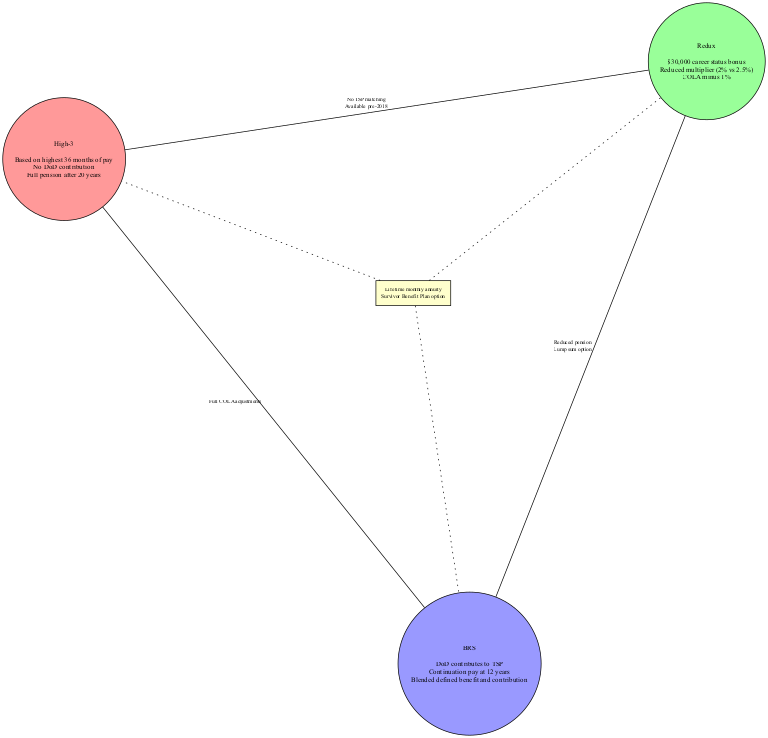What is the basis for the High-3 retirement system? The High-3 retirement system is based on the highest 36 months of pay, which is stated in the relevant section of the diagram.
Answer: highest 36 months of pay Which retirement system offers a career status bonus? The Redux retirement system specifically highlights the $30,000 career status bonus, which can be found in the elements listed under Redux.
Answer: $30,000 career status bonus What do both Redux and BRS share in terms of pension? Both Redux and BRS share the elements that mention reduced pension and lump sum option; these elements appear in the intersection between the two systems.
Answer: Reduced pension, lump sum option Which systems have no DoD contribution? The High-3 and Redux systems both indicate 'No DoD contribution' as unique elements. This can be inferred from their individual characteristics in the diagram.
Answer: High-3, Redux How many main retirement systems are defined in the diagram? The diagram visualizes three main retirement systems: High-3, Redux, and BRS; this can be counted directly from the distinct sets.
Answer: 3 Which element is common to all three systems? The element that is common to all three systems is a lifetime monthly annuity and the survivor benefit plan option, which is presented in the intersection of all three sets.
Answer: Lifetime monthly annuity, Survivor Benefit Plan option What type of pay does BRS include as a feature? BRS includes DoD contributions to the Thrift Savings Plan (TSP) as one of its distinctive features, shown clearly in its section of the diagram.
Answer: DoD contributes to TSP What distinguishes High-3 from BRS in terms of cost-of-living adjustments? High-3 offers full COLA adjustments, while BRS does not provide this as a feature. The distinction can be identified within the specific characteristics of each system in the diagram.
Answer: Full COLA adjustments Which two systems were available prior to 2018? The systems High-3 and Redux were both available before 2018, as it is indicated in their overlapping features in the diagram.
Answer: High-3, Redux 